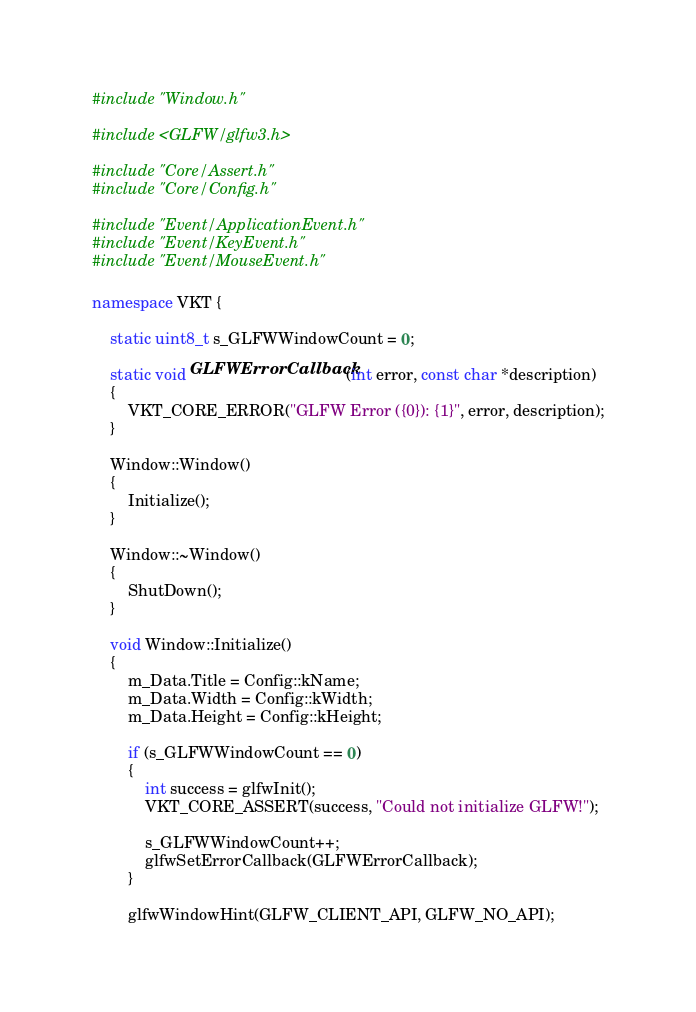<code> <loc_0><loc_0><loc_500><loc_500><_C++_>#include "Window.h"

#include <GLFW/glfw3.h>

#include "Core/Assert.h"
#include "Core/Config.h"

#include "Event/ApplicationEvent.h"
#include "Event/KeyEvent.h"
#include "Event/MouseEvent.h"

namespace VKT {

    static uint8_t s_GLFWWindowCount = 0;

    static void GLFWErrorCallback(int error, const char *description)
    {
        VKT_CORE_ERROR("GLFW Error ({0}): {1}", error, description);
    }

    Window::Window()
    {
        Initialize();
    }

    Window::~Window()
    {
        ShutDown();
    }

    void Window::Initialize()
    {
        m_Data.Title = Config::kName;
        m_Data.Width = Config::kWidth;
        m_Data.Height = Config::kHeight;

        if (s_GLFWWindowCount == 0)
        {
            int success = glfwInit();
            VKT_CORE_ASSERT(success, "Could not initialize GLFW!");

            s_GLFWWindowCount++;
            glfwSetErrorCallback(GLFWErrorCallback);
        }

        glfwWindowHint(GLFW_CLIENT_API, GLFW_NO_API);</code> 